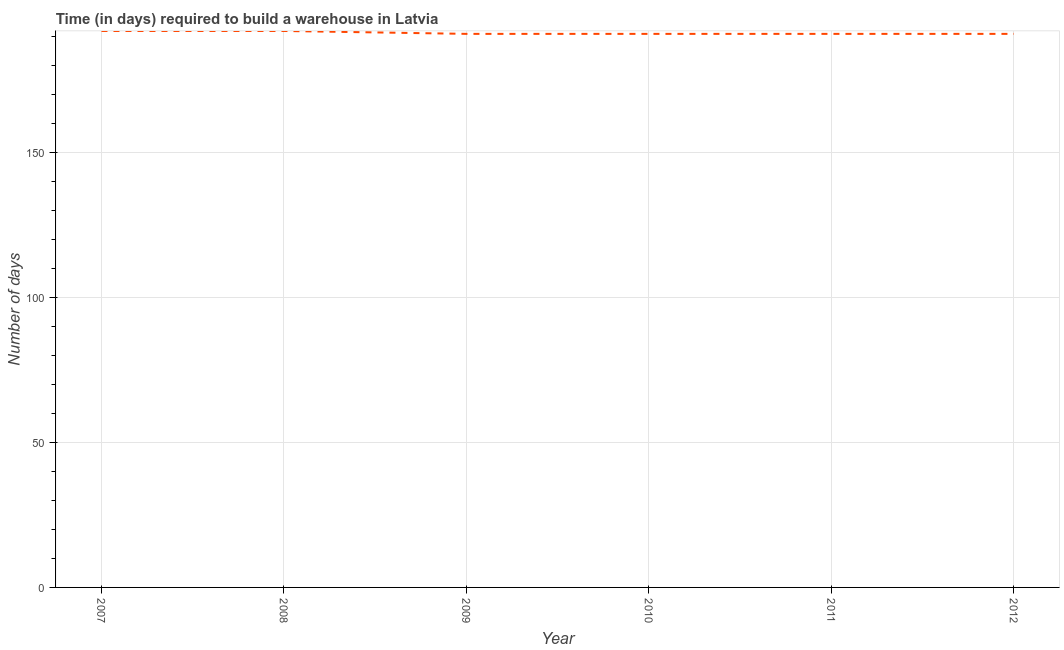What is the time required to build a warehouse in 2011?
Provide a short and direct response. 191. Across all years, what is the maximum time required to build a warehouse?
Make the answer very short. 192. Across all years, what is the minimum time required to build a warehouse?
Ensure brevity in your answer.  191. In which year was the time required to build a warehouse maximum?
Your answer should be compact. 2007. In which year was the time required to build a warehouse minimum?
Offer a terse response. 2009. What is the sum of the time required to build a warehouse?
Provide a short and direct response. 1148. What is the average time required to build a warehouse per year?
Your answer should be compact. 191.33. What is the median time required to build a warehouse?
Your answer should be compact. 191. In how many years, is the time required to build a warehouse greater than 160 days?
Keep it short and to the point. 6. Do a majority of the years between 2012 and 2008 (inclusive) have time required to build a warehouse greater than 70 days?
Offer a very short reply. Yes. What is the ratio of the time required to build a warehouse in 2007 to that in 2009?
Keep it short and to the point. 1.01. Is the time required to build a warehouse in 2011 less than that in 2012?
Give a very brief answer. No. Is the difference between the time required to build a warehouse in 2010 and 2012 greater than the difference between any two years?
Offer a terse response. No. What is the difference between the highest and the second highest time required to build a warehouse?
Provide a succinct answer. 0. What is the difference between the highest and the lowest time required to build a warehouse?
Offer a very short reply. 1. In how many years, is the time required to build a warehouse greater than the average time required to build a warehouse taken over all years?
Provide a succinct answer. 2. Does the time required to build a warehouse monotonically increase over the years?
Your answer should be compact. No. How many years are there in the graph?
Keep it short and to the point. 6. Are the values on the major ticks of Y-axis written in scientific E-notation?
Offer a terse response. No. What is the title of the graph?
Ensure brevity in your answer.  Time (in days) required to build a warehouse in Latvia. What is the label or title of the Y-axis?
Offer a very short reply. Number of days. What is the Number of days in 2007?
Provide a succinct answer. 192. What is the Number of days in 2008?
Ensure brevity in your answer.  192. What is the Number of days in 2009?
Make the answer very short. 191. What is the Number of days of 2010?
Provide a succinct answer. 191. What is the Number of days in 2011?
Offer a terse response. 191. What is the Number of days in 2012?
Give a very brief answer. 191. What is the difference between the Number of days in 2008 and 2009?
Provide a succinct answer. 1. What is the difference between the Number of days in 2008 and 2010?
Your answer should be very brief. 1. What is the difference between the Number of days in 2008 and 2012?
Make the answer very short. 1. What is the difference between the Number of days in 2009 and 2012?
Provide a succinct answer. 0. What is the difference between the Number of days in 2010 and 2011?
Provide a short and direct response. 0. What is the difference between the Number of days in 2011 and 2012?
Give a very brief answer. 0. What is the ratio of the Number of days in 2007 to that in 2008?
Offer a terse response. 1. What is the ratio of the Number of days in 2007 to that in 2011?
Keep it short and to the point. 1. What is the ratio of the Number of days in 2008 to that in 2010?
Offer a terse response. 1. What is the ratio of the Number of days in 2009 to that in 2010?
Ensure brevity in your answer.  1. What is the ratio of the Number of days in 2009 to that in 2011?
Keep it short and to the point. 1. What is the ratio of the Number of days in 2009 to that in 2012?
Provide a succinct answer. 1. What is the ratio of the Number of days in 2010 to that in 2011?
Your response must be concise. 1. What is the ratio of the Number of days in 2010 to that in 2012?
Your response must be concise. 1. What is the ratio of the Number of days in 2011 to that in 2012?
Provide a short and direct response. 1. 